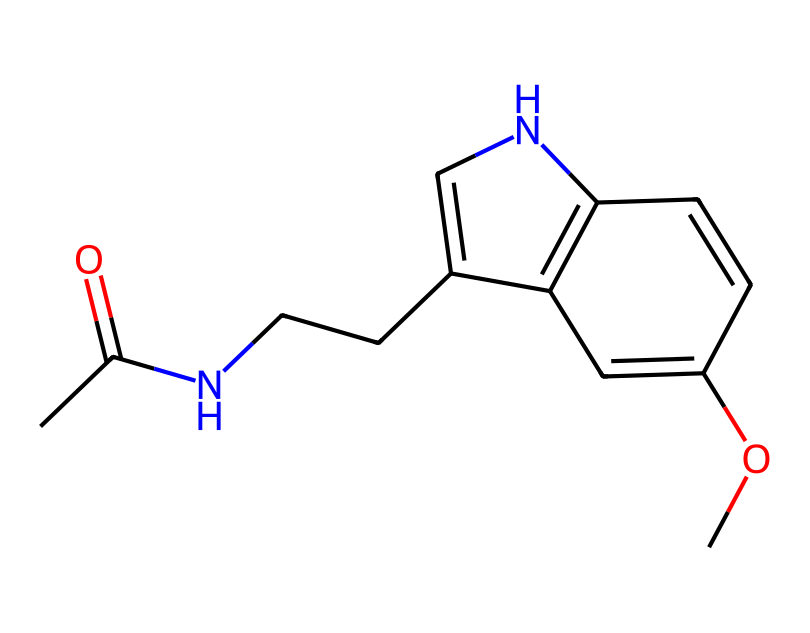What is the name of this chemical? The SMILES representation indicates that the structure corresponds to melatonin, a hormone associated with regulating sleep patterns.
Answer: melatonin How many carbon atoms are present in this compound? Counting the carbon atoms from the SMILES representation demonstrates that there are 13 carbon atoms in total within the structure.
Answer: 13 What type of bond connects the ammonia group (NH) to the rest of the molecule? The connection to the ammonia group is done via a single bond, specifically a carbon-nitrogen single bond based on the structure.
Answer: single bond What functional group is indicated by the "CC(=O)" part of the SMILES? The "CC(=O)" portion indicates the presence of a carbonyl group (C=O), which is part of the acetamide functional group in melatonin.
Answer: acetamide Which ring structure is found in this molecule? An examination of the structure reveals a bicyclic indole framework, which is characteristic of the melatonin structure.
Answer: bicyclic indole How many double bonds are present in this molecule? By analyzing the SMILES representation, it is clear that there are 5 double bonds associated with the molecular structure of melatonin.
Answer: 5 What is the primary role of melatonin? Melatonin primarily regulates sleep patterns, facilitating the transition to sleep in humans, particularly during night hours.
Answer: regulate sleep 